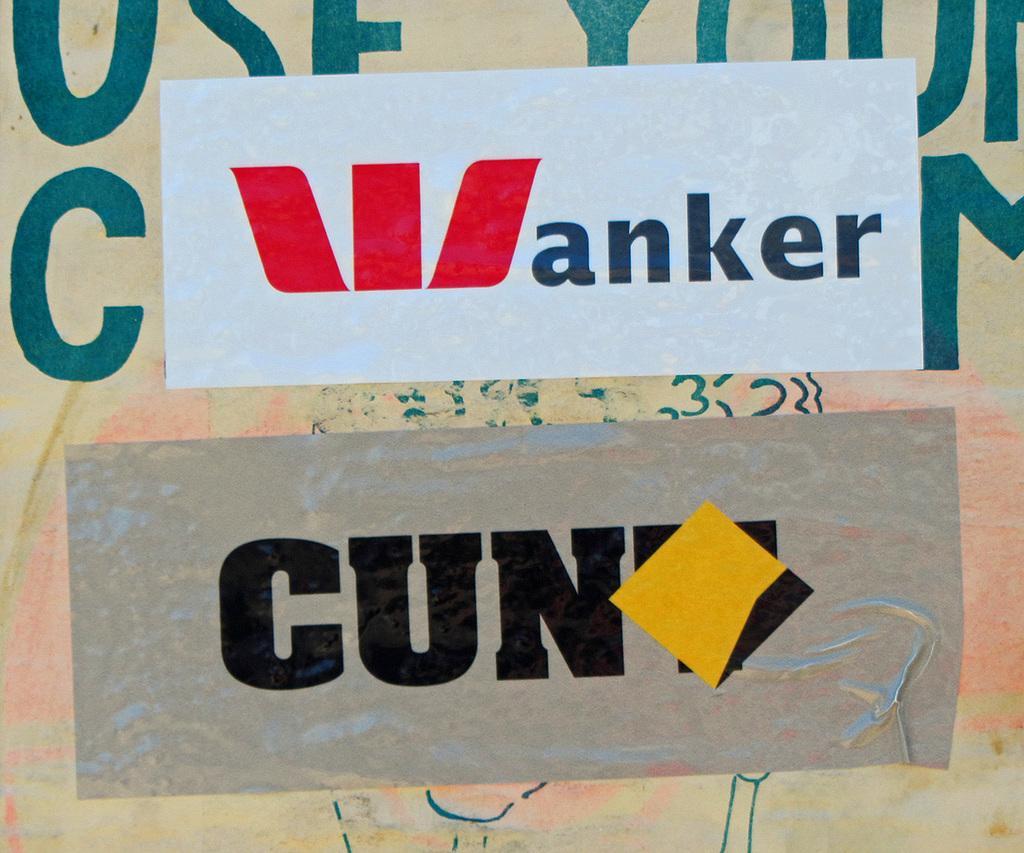Describe this image in one or two sentences. In this image there is a wall with a text on it. In the middle of the image there are two posters on the wall with a text on them. 